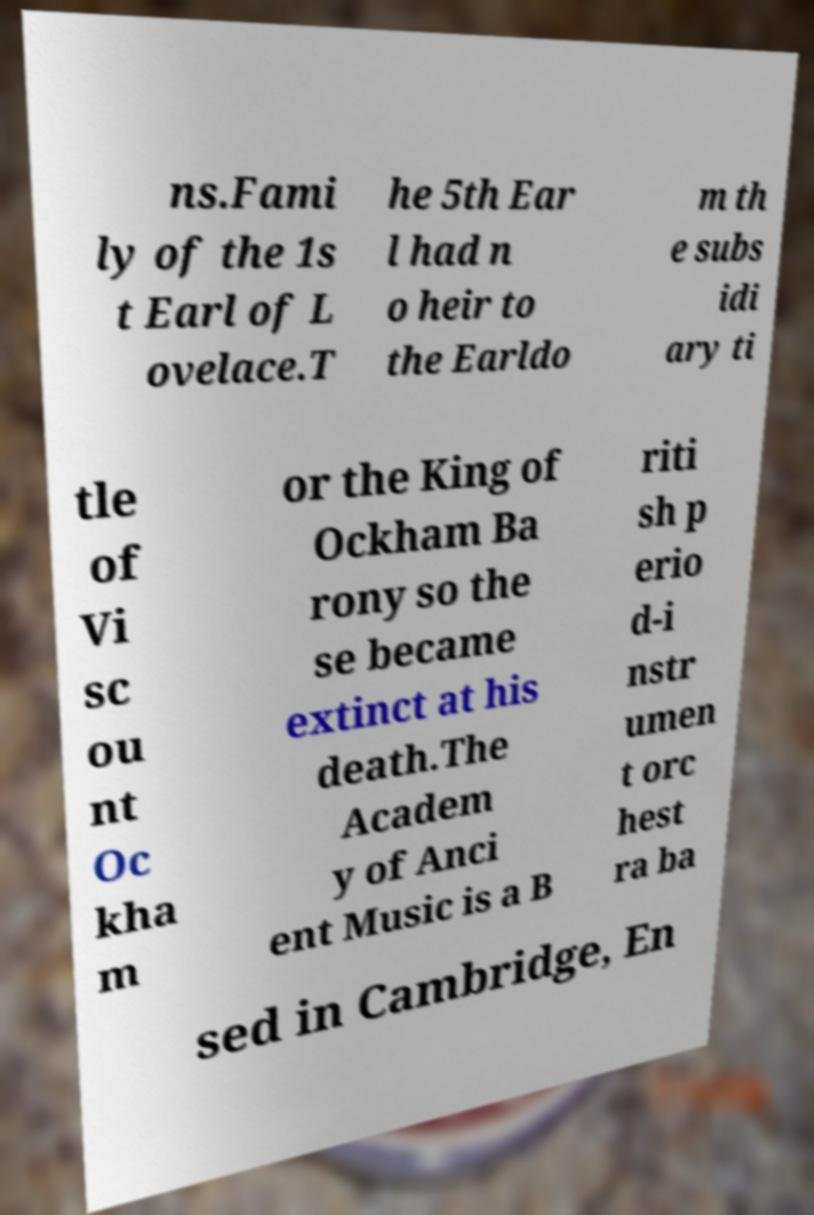Could you assist in decoding the text presented in this image and type it out clearly? ns.Fami ly of the 1s t Earl of L ovelace.T he 5th Ear l had n o heir to the Earldo m th e subs idi ary ti tle of Vi sc ou nt Oc kha m or the King of Ockham Ba rony so the se became extinct at his death.The Academ y of Anci ent Music is a B riti sh p erio d-i nstr umen t orc hest ra ba sed in Cambridge, En 